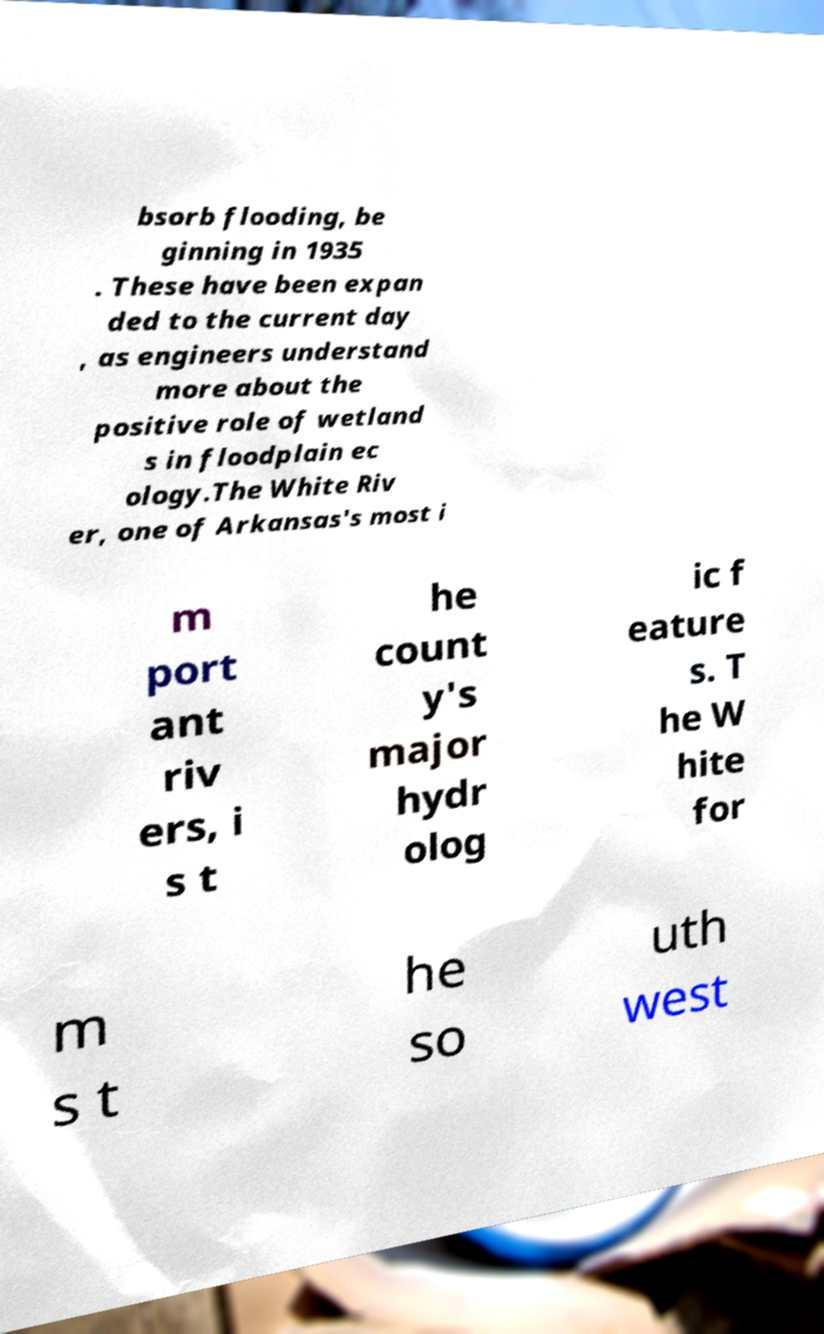Could you assist in decoding the text presented in this image and type it out clearly? bsorb flooding, be ginning in 1935 . These have been expan ded to the current day , as engineers understand more about the positive role of wetland s in floodplain ec ology.The White Riv er, one of Arkansas's most i m port ant riv ers, i s t he count y's major hydr olog ic f eature s. T he W hite for m s t he so uth west 